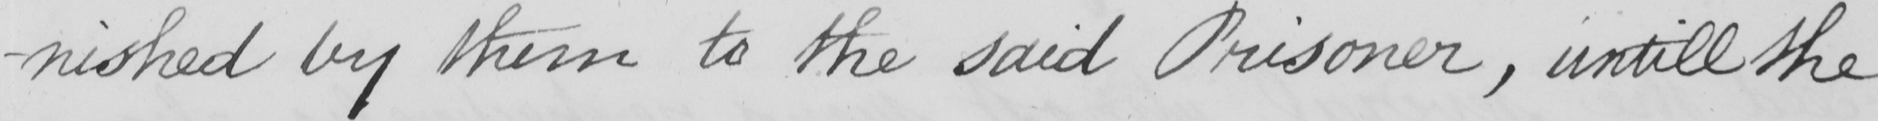Transcribe the text shown in this historical manuscript line. -nished by them to the said Prisoner , untill the 